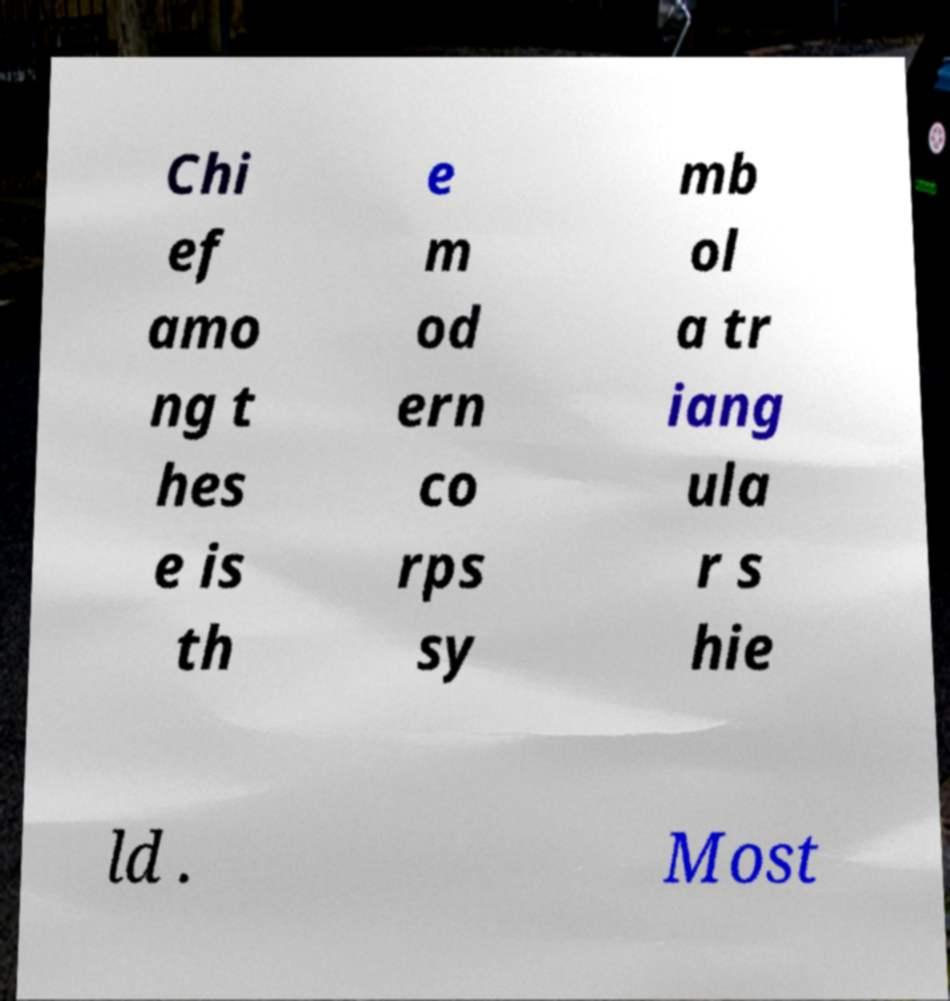For documentation purposes, I need the text within this image transcribed. Could you provide that? Chi ef amo ng t hes e is th e m od ern co rps sy mb ol a tr iang ula r s hie ld . Most 